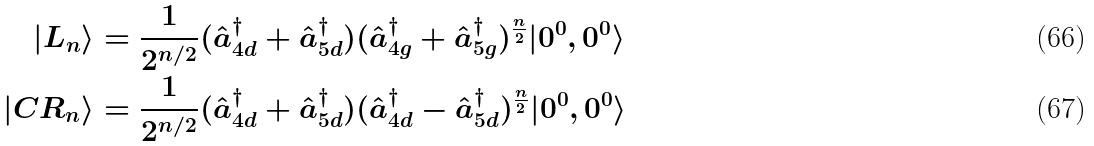<formula> <loc_0><loc_0><loc_500><loc_500>| L _ { n } \rangle & = \frac { 1 } { 2 ^ { { n } / { 2 } } } ( \hat { a } _ { 4 d } ^ { \dagger } + \hat { a } _ { 5 d } ^ { \dagger } ) ( \hat { a } _ { 4 g } ^ { \dagger } + \hat { a } _ { 5 g } ^ { \dagger } ) ^ { \frac { n } { 2 } } | 0 ^ { 0 } , 0 ^ { 0 } \rangle \\ | C R _ { n } \rangle & = \frac { 1 } { 2 ^ { { n } / { 2 } } } ( \hat { a } _ { 4 d } ^ { \dagger } + \hat { a } _ { 5 d } ^ { \dagger } ) ( \hat { a } _ { 4 d } ^ { \dagger } - \hat { a } _ { 5 d } ^ { \dagger } ) ^ { \frac { n } { 2 } } | 0 ^ { 0 } , 0 ^ { 0 } \rangle</formula> 